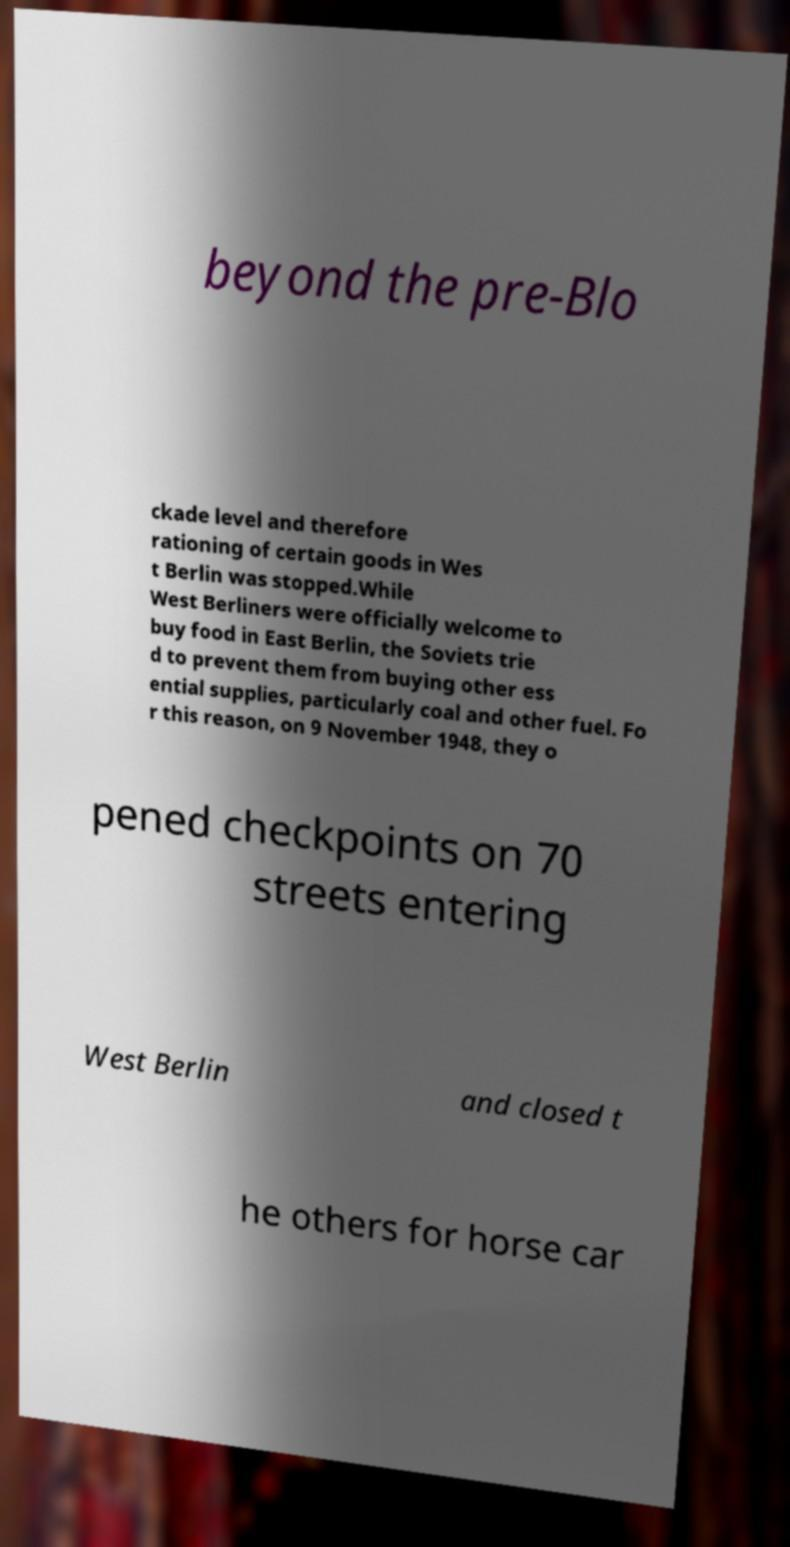Please read and relay the text visible in this image. What does it say? beyond the pre-Blo ckade level and therefore rationing of certain goods in Wes t Berlin was stopped.While West Berliners were officially welcome to buy food in East Berlin, the Soviets trie d to prevent them from buying other ess ential supplies, particularly coal and other fuel. Fo r this reason, on 9 November 1948, they o pened checkpoints on 70 streets entering West Berlin and closed t he others for horse car 